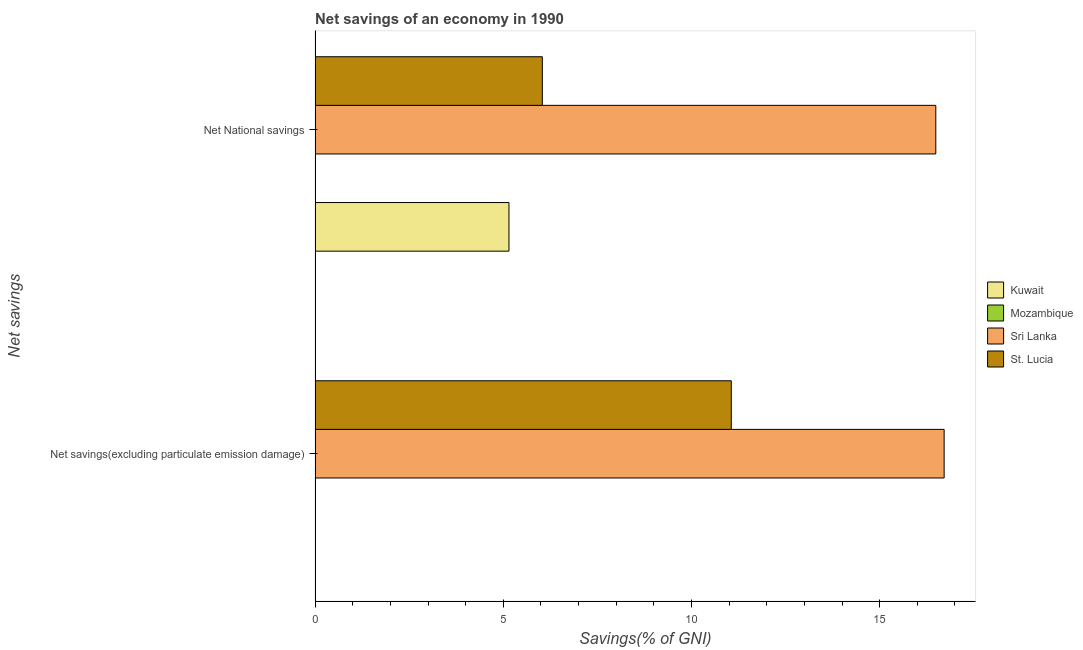How many different coloured bars are there?
Your answer should be very brief. 3. How many bars are there on the 1st tick from the top?
Keep it short and to the point. 3. How many bars are there on the 1st tick from the bottom?
Your answer should be very brief. 2. What is the label of the 2nd group of bars from the top?
Your response must be concise. Net savings(excluding particulate emission damage). Across all countries, what is the maximum net savings(excluding particulate emission damage)?
Your response must be concise. 16.71. In which country was the net savings(excluding particulate emission damage) maximum?
Provide a succinct answer. Sri Lanka. What is the total net national savings in the graph?
Provide a short and direct response. 27.68. What is the difference between the net national savings in Sri Lanka and that in Kuwait?
Offer a very short reply. 11.34. What is the difference between the net savings(excluding particulate emission damage) in Sri Lanka and the net national savings in St. Lucia?
Provide a short and direct response. 10.68. What is the average net national savings per country?
Offer a very short reply. 6.92. What is the difference between the net savings(excluding particulate emission damage) and net national savings in Sri Lanka?
Keep it short and to the point. 0.22. What is the ratio of the net national savings in St. Lucia to that in Kuwait?
Your response must be concise. 1.17. Are the values on the major ticks of X-axis written in scientific E-notation?
Offer a terse response. No. Does the graph contain any zero values?
Provide a short and direct response. Yes. Where does the legend appear in the graph?
Provide a succinct answer. Center right. What is the title of the graph?
Provide a short and direct response. Net savings of an economy in 1990. What is the label or title of the X-axis?
Your answer should be very brief. Savings(% of GNI). What is the label or title of the Y-axis?
Offer a very short reply. Net savings. What is the Savings(% of GNI) in Kuwait in Net savings(excluding particulate emission damage)?
Your answer should be very brief. 0. What is the Savings(% of GNI) in Sri Lanka in Net savings(excluding particulate emission damage)?
Provide a succinct answer. 16.71. What is the Savings(% of GNI) of St. Lucia in Net savings(excluding particulate emission damage)?
Give a very brief answer. 11.06. What is the Savings(% of GNI) of Kuwait in Net National savings?
Provide a short and direct response. 5.15. What is the Savings(% of GNI) of Sri Lanka in Net National savings?
Provide a succinct answer. 16.49. What is the Savings(% of GNI) of St. Lucia in Net National savings?
Give a very brief answer. 6.04. Across all Net savings, what is the maximum Savings(% of GNI) of Kuwait?
Make the answer very short. 5.15. Across all Net savings, what is the maximum Savings(% of GNI) of Sri Lanka?
Ensure brevity in your answer.  16.71. Across all Net savings, what is the maximum Savings(% of GNI) of St. Lucia?
Your answer should be very brief. 11.06. Across all Net savings, what is the minimum Savings(% of GNI) in Kuwait?
Ensure brevity in your answer.  0. Across all Net savings, what is the minimum Savings(% of GNI) in Sri Lanka?
Your response must be concise. 16.49. Across all Net savings, what is the minimum Savings(% of GNI) in St. Lucia?
Make the answer very short. 6.04. What is the total Savings(% of GNI) in Kuwait in the graph?
Your answer should be compact. 5.15. What is the total Savings(% of GNI) of Mozambique in the graph?
Provide a succinct answer. 0. What is the total Savings(% of GNI) of Sri Lanka in the graph?
Ensure brevity in your answer.  33.21. What is the total Savings(% of GNI) in St. Lucia in the graph?
Your response must be concise. 17.1. What is the difference between the Savings(% of GNI) of Sri Lanka in Net savings(excluding particulate emission damage) and that in Net National savings?
Offer a terse response. 0.22. What is the difference between the Savings(% of GNI) of St. Lucia in Net savings(excluding particulate emission damage) and that in Net National savings?
Provide a short and direct response. 5.02. What is the difference between the Savings(% of GNI) of Sri Lanka in Net savings(excluding particulate emission damage) and the Savings(% of GNI) of St. Lucia in Net National savings?
Provide a succinct answer. 10.68. What is the average Savings(% of GNI) of Kuwait per Net savings?
Your response must be concise. 2.58. What is the average Savings(% of GNI) in Mozambique per Net savings?
Your answer should be very brief. 0. What is the average Savings(% of GNI) of Sri Lanka per Net savings?
Provide a short and direct response. 16.6. What is the average Savings(% of GNI) of St. Lucia per Net savings?
Ensure brevity in your answer.  8.55. What is the difference between the Savings(% of GNI) of Sri Lanka and Savings(% of GNI) of St. Lucia in Net savings(excluding particulate emission damage)?
Your answer should be compact. 5.66. What is the difference between the Savings(% of GNI) of Kuwait and Savings(% of GNI) of Sri Lanka in Net National savings?
Make the answer very short. -11.34. What is the difference between the Savings(% of GNI) in Kuwait and Savings(% of GNI) in St. Lucia in Net National savings?
Give a very brief answer. -0.89. What is the difference between the Savings(% of GNI) in Sri Lanka and Savings(% of GNI) in St. Lucia in Net National savings?
Provide a succinct answer. 10.45. What is the ratio of the Savings(% of GNI) of Sri Lanka in Net savings(excluding particulate emission damage) to that in Net National savings?
Offer a terse response. 1.01. What is the ratio of the Savings(% of GNI) of St. Lucia in Net savings(excluding particulate emission damage) to that in Net National savings?
Offer a very short reply. 1.83. What is the difference between the highest and the second highest Savings(% of GNI) of Sri Lanka?
Provide a short and direct response. 0.22. What is the difference between the highest and the second highest Savings(% of GNI) of St. Lucia?
Ensure brevity in your answer.  5.02. What is the difference between the highest and the lowest Savings(% of GNI) in Kuwait?
Provide a short and direct response. 5.15. What is the difference between the highest and the lowest Savings(% of GNI) of Sri Lanka?
Provide a short and direct response. 0.22. What is the difference between the highest and the lowest Savings(% of GNI) in St. Lucia?
Provide a succinct answer. 5.02. 